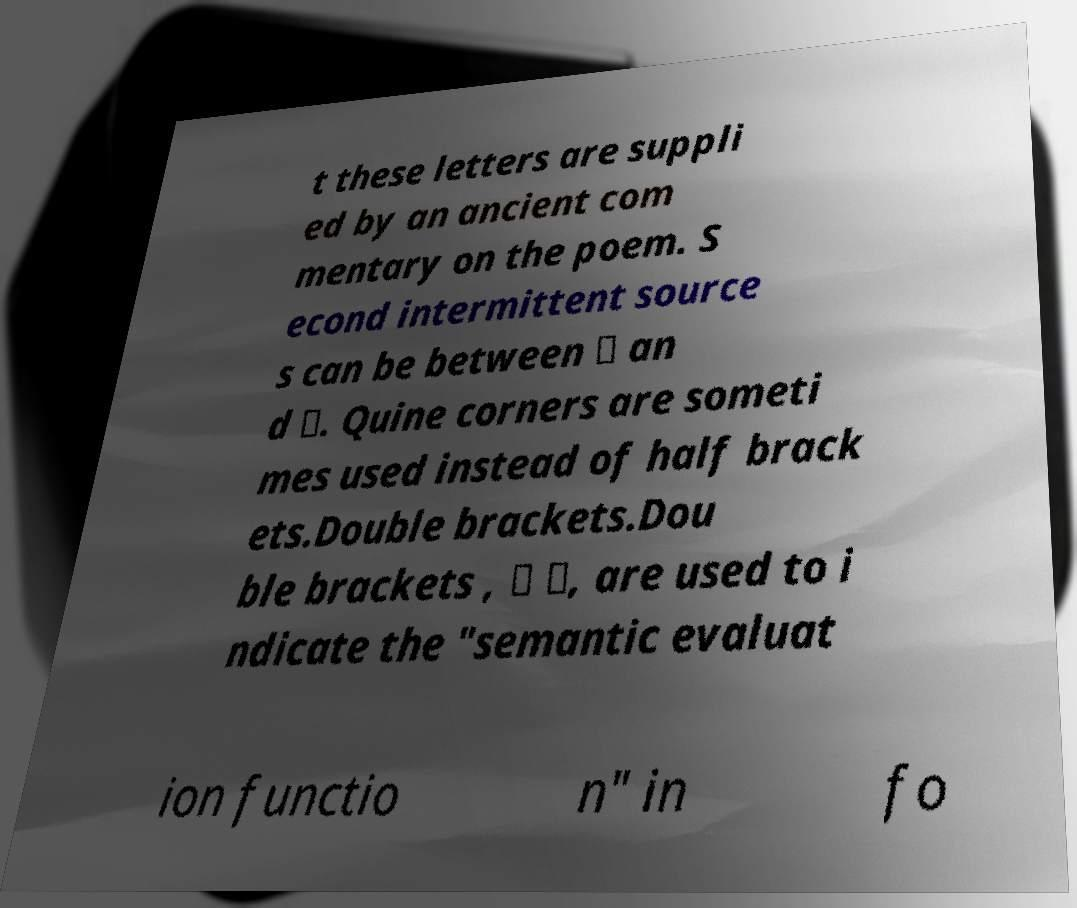What messages or text are displayed in this image? I need them in a readable, typed format. t these letters are suppli ed by an ancient com mentary on the poem. S econd intermittent source s can be between ⸢ an d ⸣. Quine corners are someti mes used instead of half brack ets.Double brackets.Dou ble brackets , ⟦ ⟧, are used to i ndicate the "semantic evaluat ion functio n" in fo 